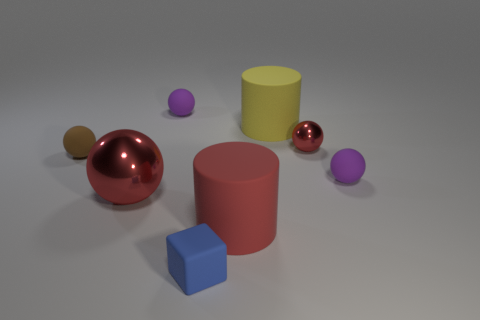What shape is the large object that is the same color as the big metallic sphere?
Your response must be concise. Cylinder. There is a cylinder behind the tiny rubber object to the left of the purple matte ball that is to the left of the block; how big is it?
Ensure brevity in your answer.  Large. Is the red matte thing the same size as the brown rubber ball?
Offer a terse response. No. What material is the cylinder behind the metal thing to the left of the tiny blue rubber block made of?
Provide a short and direct response. Rubber. Do the tiny thing that is left of the big metal thing and the red metal object to the left of the small blue rubber block have the same shape?
Offer a very short reply. Yes. Is the number of big red things to the right of the small blue matte block the same as the number of purple matte objects?
Your response must be concise. No. There is a red thing that is to the left of the tiny blue cube; are there any large cylinders in front of it?
Ensure brevity in your answer.  Yes. Is there any other thing that is the same color as the big ball?
Keep it short and to the point. Yes. Are the purple ball that is behind the yellow matte cylinder and the tiny red ball made of the same material?
Make the answer very short. No. Are there an equal number of tiny balls to the right of the large yellow cylinder and small objects behind the small blue rubber thing?
Give a very brief answer. No. 